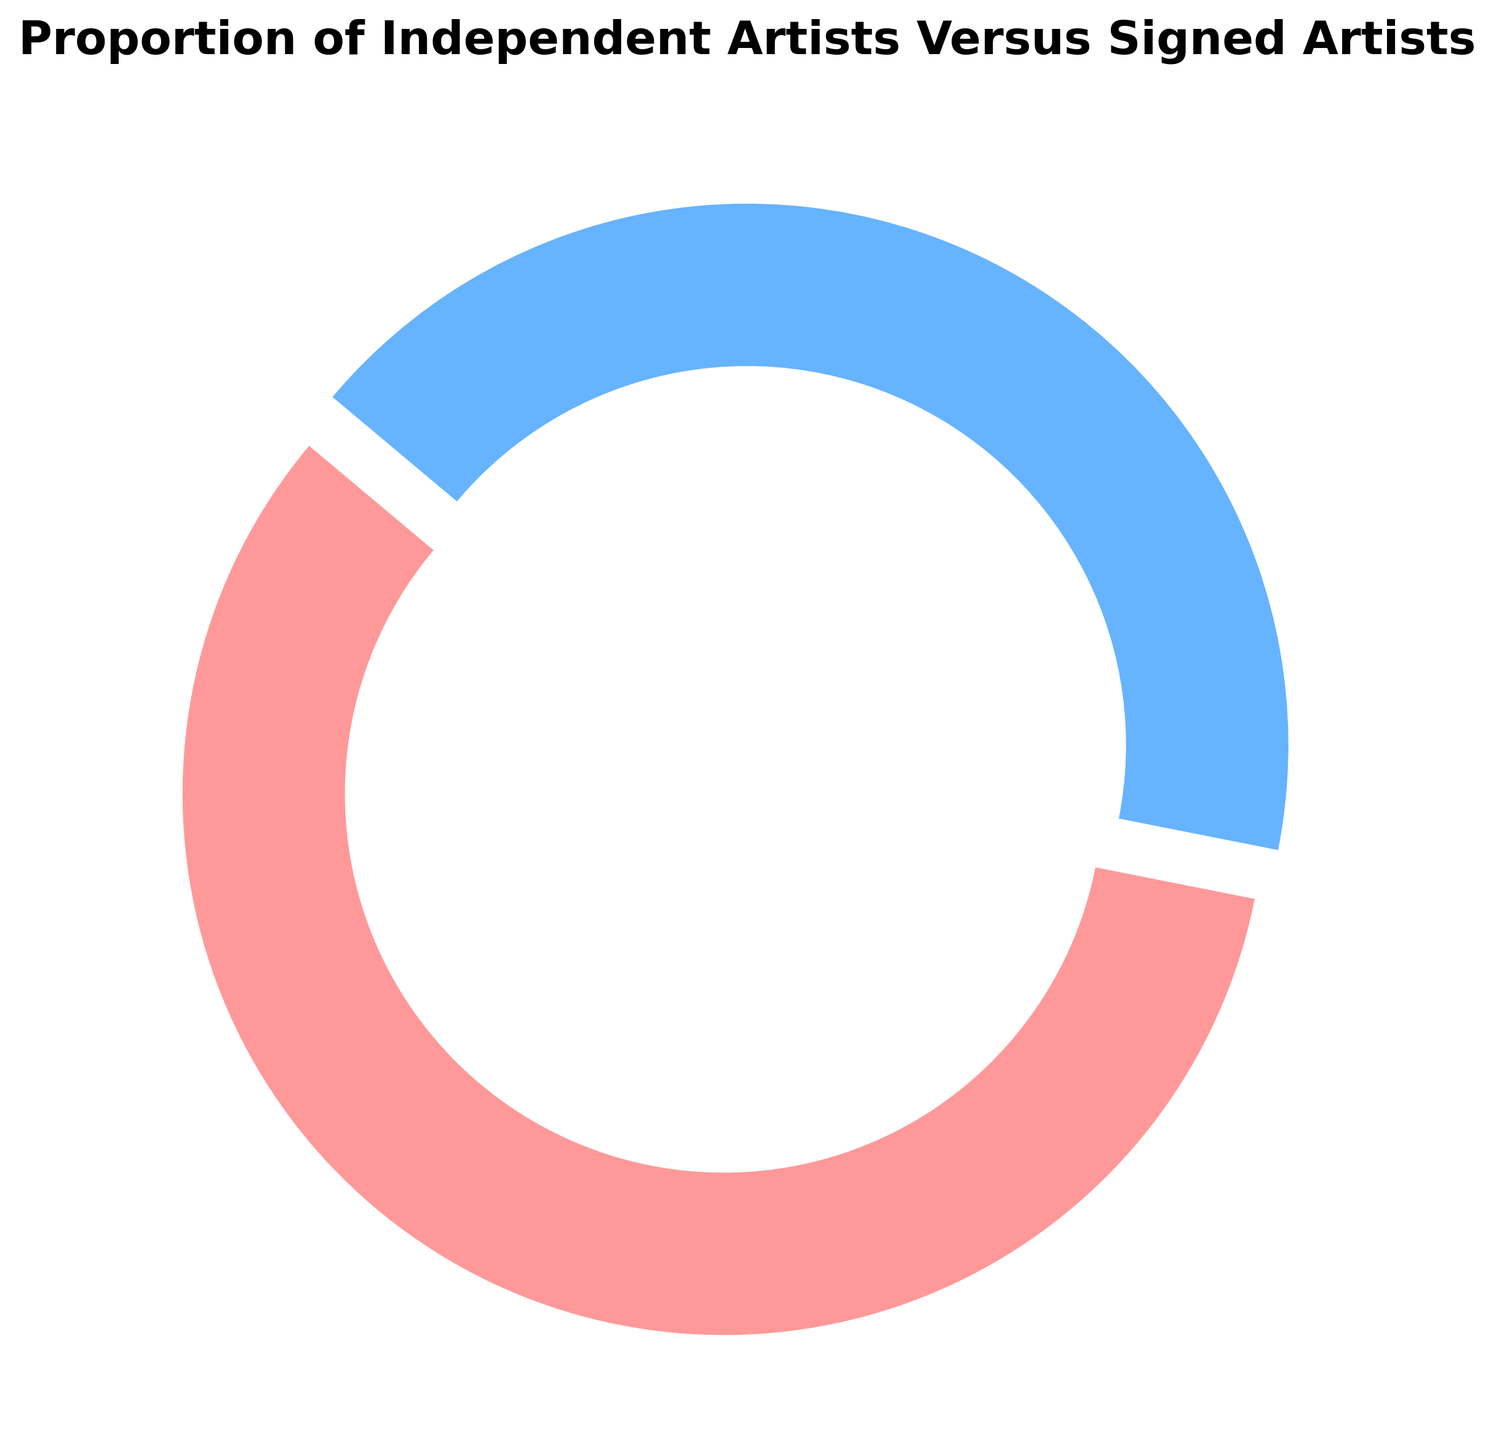What percentage of artists are independent? The ring chart shows two categories: Independent Artists and Signed Artists, with their respective percentages. The percentage for Independent Artists is labeled directly on the chart.
Answer: 58% Which category has a higher proportion of artists? Compare the percentages of the two categories shown in the ring chart: Independent Artists (58%) and Signed Artists (42%). The category with the higher percentage is the one that has the larger proportion.
Answer: Independent Artists By what percentage do Independent Artists exceed Signed Artists? Subtract the percentage of Signed Artists (42%) from the percentage of Independent Artists (58%). The result will give the percentage by which Independent Artists exceed Signed Artists.
Answer: 16% What is the total percentage of artists accounted for in the chart? Add the percentages of the two categories (Independent Artists and Signed Artists) displayed in the ring chart.
Answer: 100% What are the colors representing Independent Artists and Signed Artists? The ring chart uses different colors to distinguish between categories. The labels next to the chart segments indicate which segment corresponds to which category. Independent Artists are represented by a reddish color, and Signed Artists by a blueish color.
Answer: Reddish for Independent Artists and Blueish for Signed Artists If Signed Artists made up 25% instead of 42%, how would the percentage of Independent Artists change? The total percentage in the chart is 100%. If Signed Artists' percentage is reduced to 25%, then the percentage of Independent Artists would increase by the difference (42% - 25% = 17%). Add this difference to the current percentage of Independent Artists (58%).
Answer: 75% Which category is represented by the larger segment in the ring chart? Observe the visual size of each segment in the ring chart. The segment with the larger visual area represents the category with the higher percentage.
Answer: Independent Artists Explain how the explode effect is applied to the segments in the chart. The ring chart uses an explode effect to emphasize one segment more than the other. In this case, observe the chart segment that appears slightly separated from the center compared to the other. This is typically done to highlight the category with the most significant or notable difference.
Answer: The segment for Independent Artists is exploded What is the ratio of Independent Artists to Signed Artists? To find the ratio, divide the percentage of Independent Artists (58%) by the percentage of Signed Artists (42%). Simplify the resulting fraction if necessary.
Answer: 1.38 What does the title of the chart indicate about the data presented? The title of the chart is "Proportion of Independent Artists Versus Signed Artists." This indicates that the chart presents the comparative proportions of two categories of artists: Independent Artists and Signed Artists, within a given timeframe (the last year).
Answer: Comparative proportions of Independent and Signed Artists 